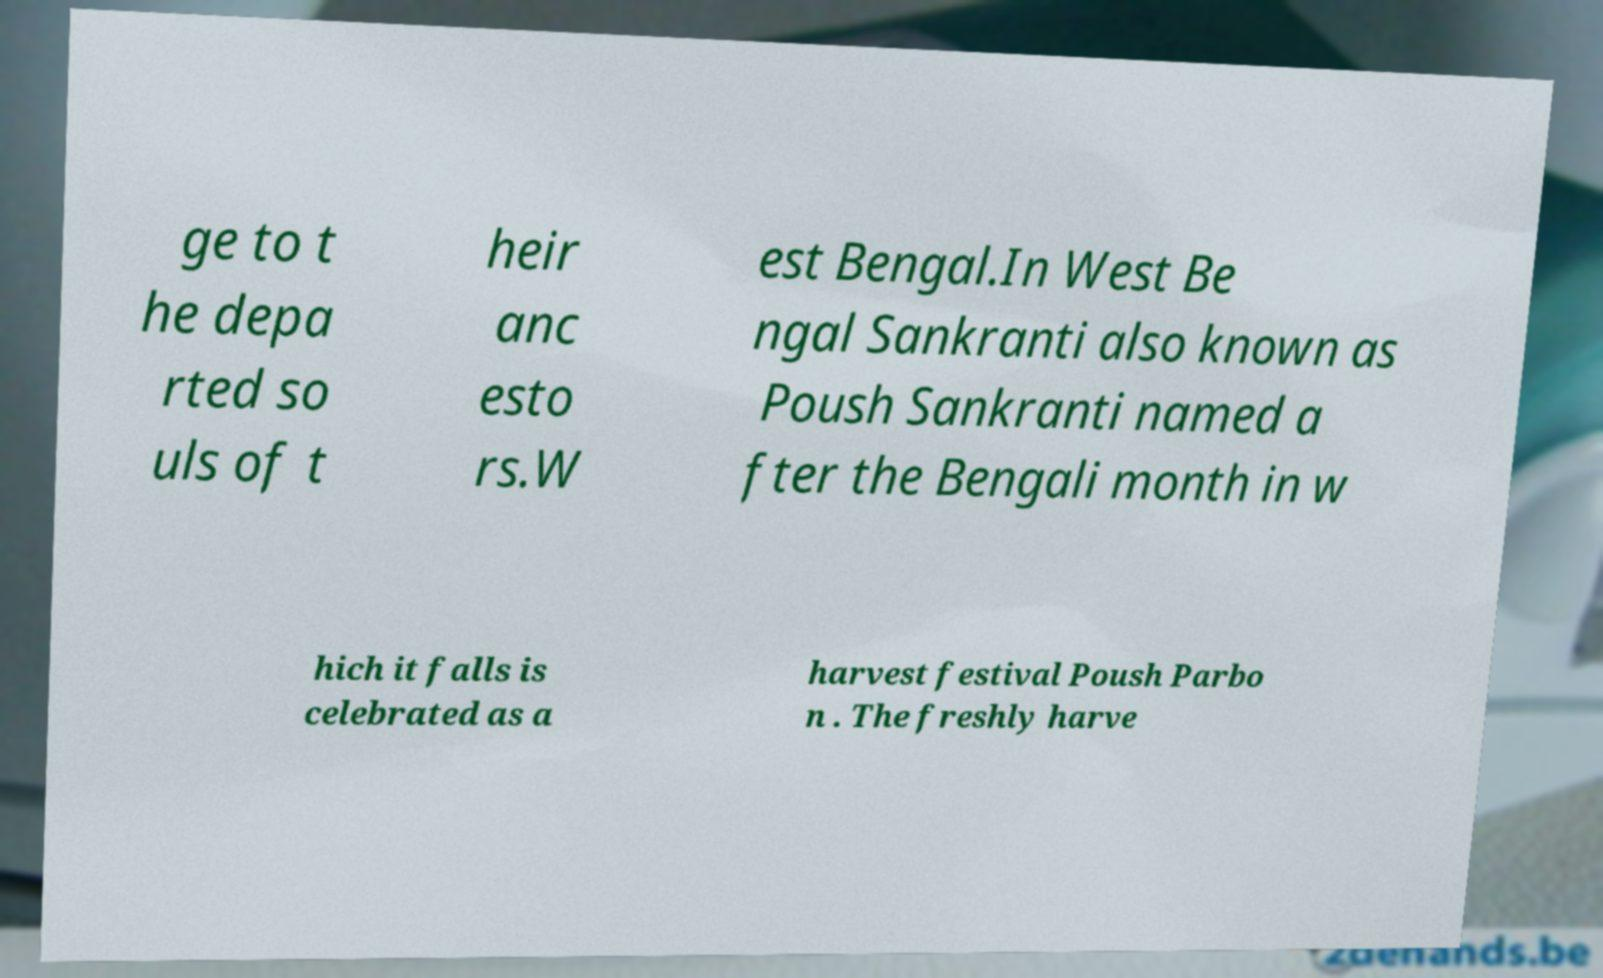Please identify and transcribe the text found in this image. ge to t he depa rted so uls of t heir anc esto rs.W est Bengal.In West Be ngal Sankranti also known as Poush Sankranti named a fter the Bengali month in w hich it falls is celebrated as a harvest festival Poush Parbo n . The freshly harve 